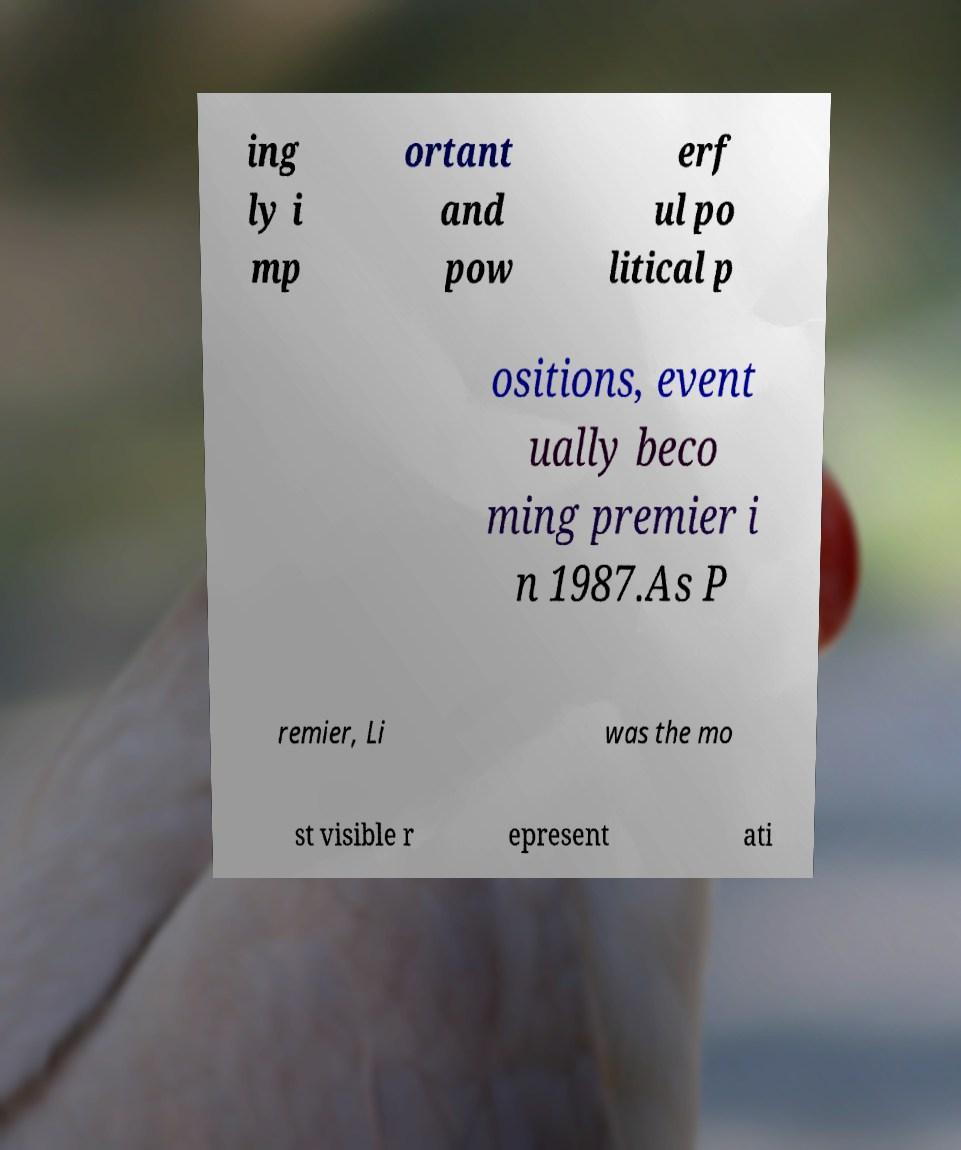Can you read and provide the text displayed in the image?This photo seems to have some interesting text. Can you extract and type it out for me? ing ly i mp ortant and pow erf ul po litical p ositions, event ually beco ming premier i n 1987.As P remier, Li was the mo st visible r epresent ati 